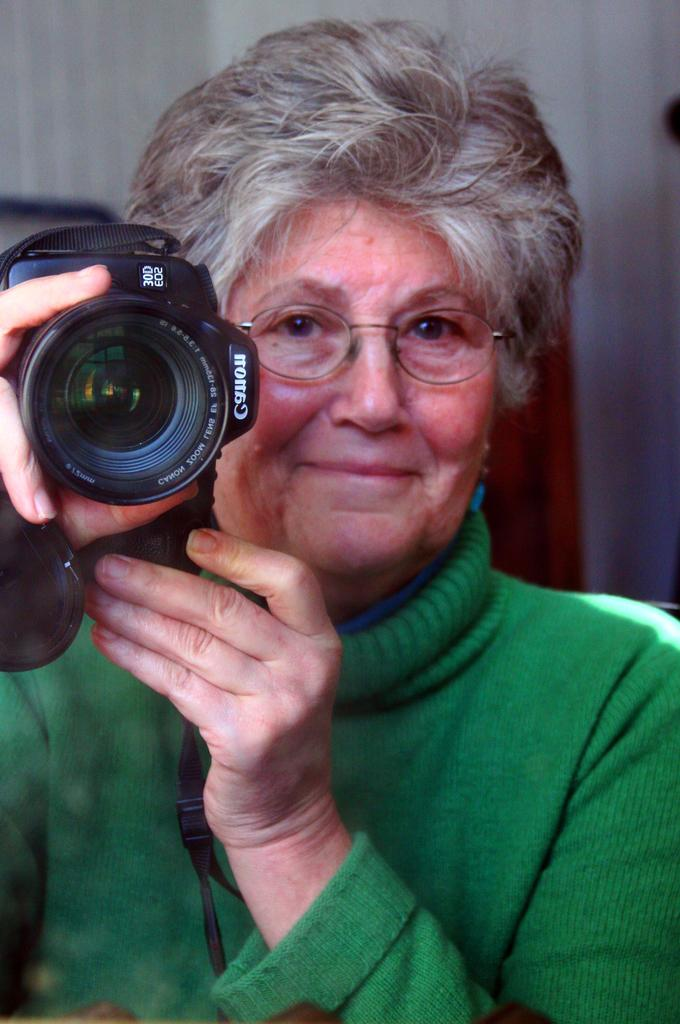What is the main subject of the image? There is a person in the image. What is the person holding in the image? The person is holding a camera. Can you describe the background of the image? The background of the image is blurred. What type of chin can be seen on the person in the image? There is no chin visible in the image, as the person's face is not shown. Is there a prison in the background of the image? There is no prison present in the image; the background is blurred. 